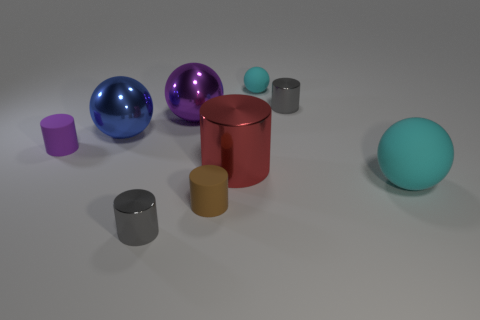Subtract all small cyan rubber balls. How many balls are left? 3 Subtract all green cylinders. How many cyan spheres are left? 2 Subtract 2 cylinders. How many cylinders are left? 3 Subtract all cylinders. How many objects are left? 4 Subtract all purple balls. How many balls are left? 3 Subtract 0 brown balls. How many objects are left? 9 Subtract all gray spheres. Subtract all yellow blocks. How many spheres are left? 4 Subtract all purple metal things. Subtract all large blue metallic spheres. How many objects are left? 7 Add 2 tiny metallic objects. How many tiny metallic objects are left? 4 Add 6 small cyan spheres. How many small cyan spheres exist? 7 